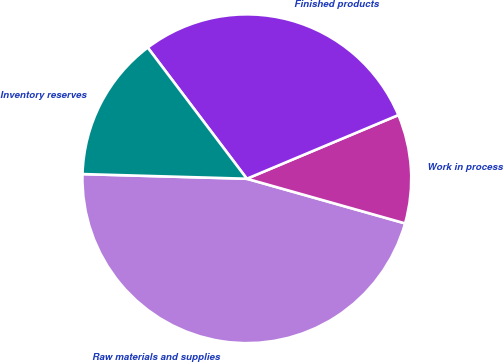<chart> <loc_0><loc_0><loc_500><loc_500><pie_chart><fcel>Raw materials and supplies<fcel>Work in process<fcel>Finished products<fcel>Inventory reserves<nl><fcel>46.08%<fcel>10.71%<fcel>28.97%<fcel>14.25%<nl></chart> 